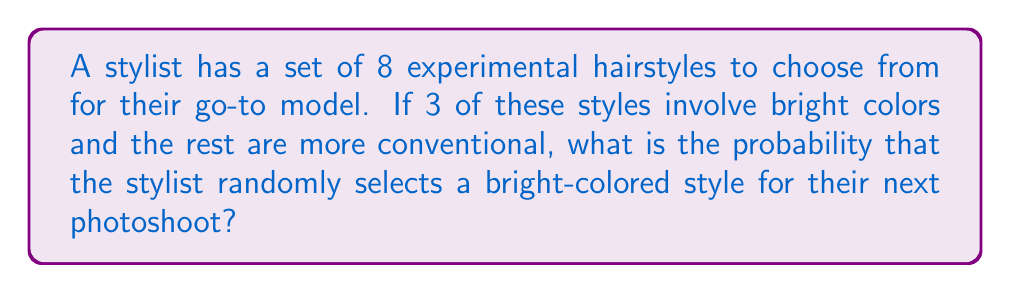Help me with this question. Let's approach this step-by-step:

1) First, we need to identify the total number of possible outcomes and the number of favorable outcomes:
   - Total number of hairstyles: 8
   - Number of bright-colored styles: 3

2) The probability of an event is calculated by dividing the number of favorable outcomes by the total number of possible outcomes:

   $$P(\text{event}) = \frac{\text{favorable outcomes}}{\text{total outcomes}}$$

3) In this case:
   $$P(\text{bright color}) = \frac{3}{8}$$

4) This fraction can be reduced, but it's already in its simplest form.

5) To express this as a decimal, we can divide 3 by 8:
   $$\frac{3}{8} = 0.375$$

6) To express as a percentage, multiply by 100:
   $$0.375 \times 100 = 37.5\%$$

Thus, the probability of the stylist randomly selecting a bright-colored style is $\frac{3}{8}$, 0.375, or 37.5%.
Answer: $\frac{3}{8}$ 